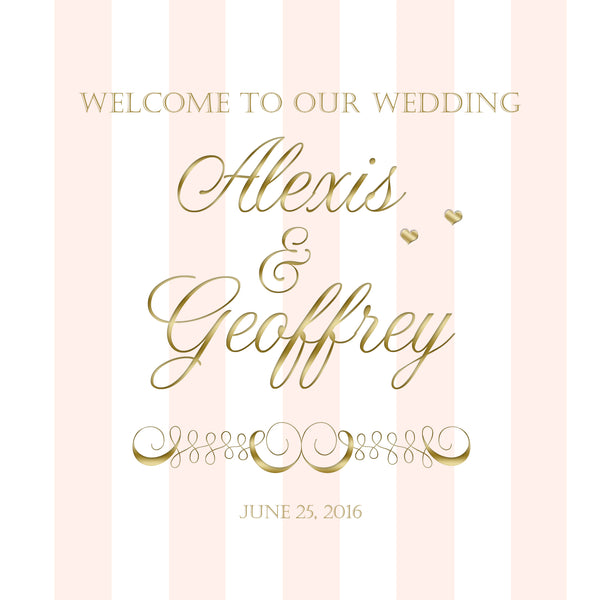The invitation features a soft pink background with gold text, names 'Alexis & Geoffrey,' and the date 'June 25, 2016'. What style or theme does this wedding invitation suggest? Based on the design elements, this wedding invitation suggests a classic and elegant theme. The use of gold accents gives it a luxurious feel, while the soft pink background adds a touch of romance and sophistication. It likely indicates a formal or semi-formal event, possibly held in a refined venue such as a garden, country club, or ballroom. 